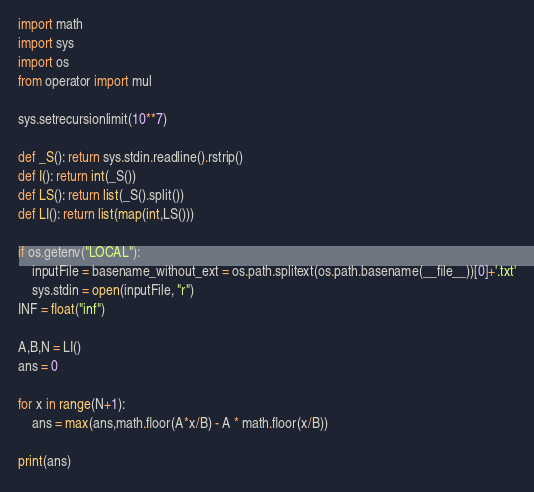<code> <loc_0><loc_0><loc_500><loc_500><_Python_>import math
import sys
import os
from operator import mul

sys.setrecursionlimit(10**7)

def _S(): return sys.stdin.readline().rstrip()
def I(): return int(_S())
def LS(): return list(_S().split())
def LI(): return list(map(int,LS()))

if os.getenv("LOCAL"):
    inputFile = basename_without_ext = os.path.splitext(os.path.basename(__file__))[0]+'.txt'
    sys.stdin = open(inputFile, "r")
INF = float("inf")

A,B,N = LI()
ans = 0

for x in range(N+1):
    ans = max(ans,math.floor(A*x/B) - A * math.floor(x/B))

print(ans)</code> 